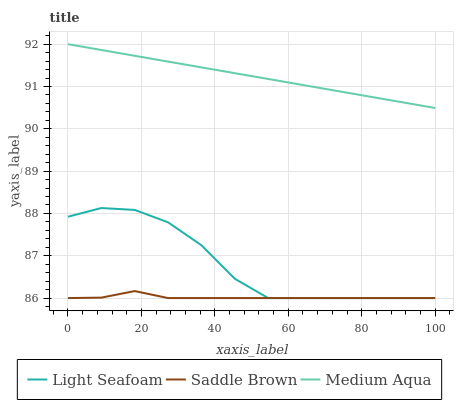Does Saddle Brown have the minimum area under the curve?
Answer yes or no. Yes. Does Medium Aqua have the maximum area under the curve?
Answer yes or no. Yes. Does Medium Aqua have the minimum area under the curve?
Answer yes or no. No. Does Saddle Brown have the maximum area under the curve?
Answer yes or no. No. Is Medium Aqua the smoothest?
Answer yes or no. Yes. Is Light Seafoam the roughest?
Answer yes or no. Yes. Is Saddle Brown the smoothest?
Answer yes or no. No. Is Saddle Brown the roughest?
Answer yes or no. No. Does Light Seafoam have the lowest value?
Answer yes or no. Yes. Does Medium Aqua have the lowest value?
Answer yes or no. No. Does Medium Aqua have the highest value?
Answer yes or no. Yes. Does Saddle Brown have the highest value?
Answer yes or no. No. Is Light Seafoam less than Medium Aqua?
Answer yes or no. Yes. Is Medium Aqua greater than Saddle Brown?
Answer yes or no. Yes. Does Saddle Brown intersect Light Seafoam?
Answer yes or no. Yes. Is Saddle Brown less than Light Seafoam?
Answer yes or no. No. Is Saddle Brown greater than Light Seafoam?
Answer yes or no. No. Does Light Seafoam intersect Medium Aqua?
Answer yes or no. No. 